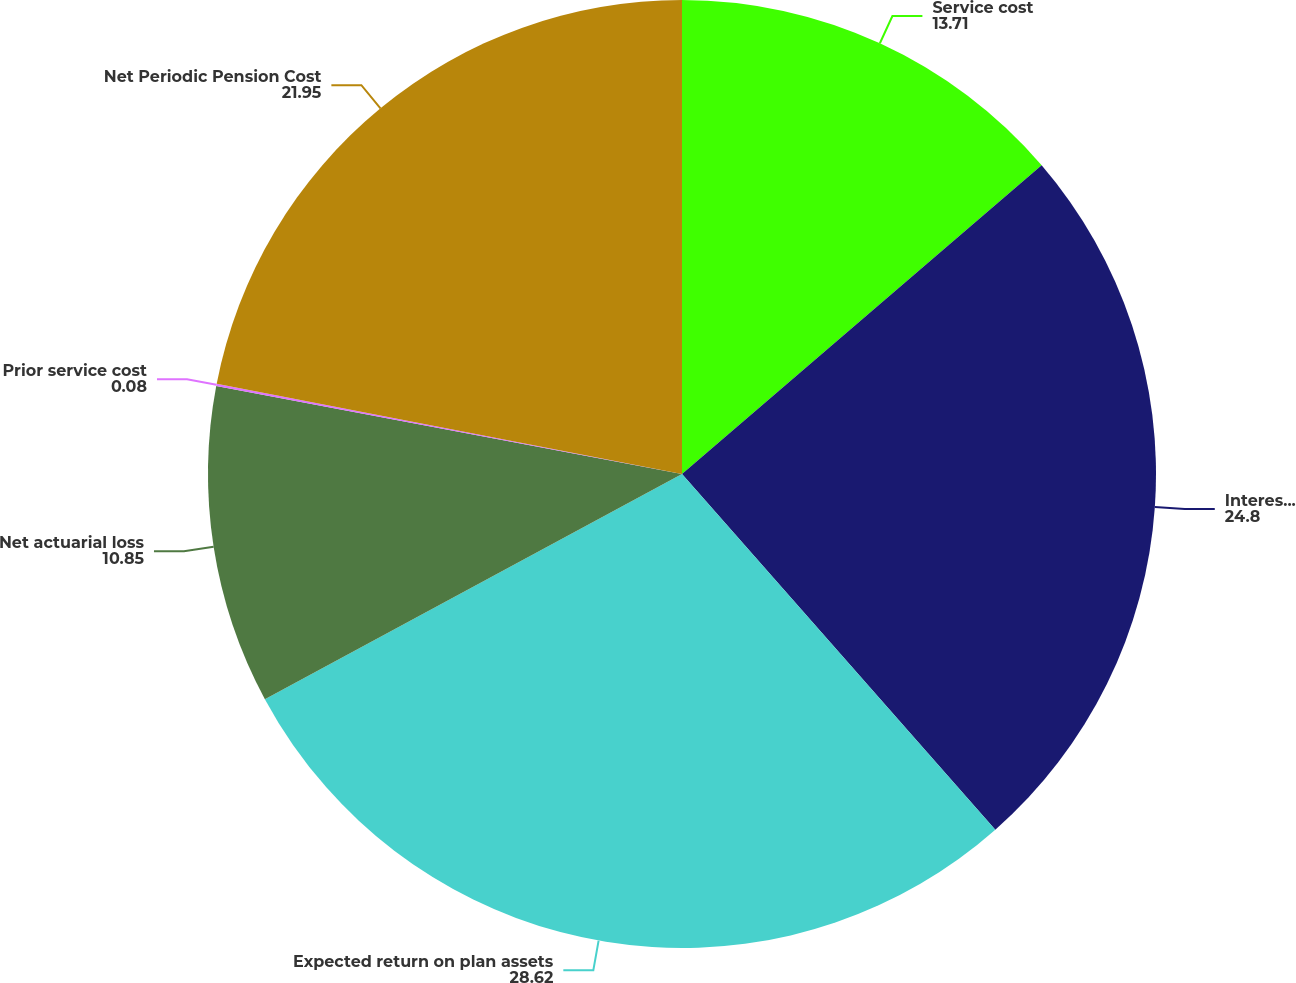<chart> <loc_0><loc_0><loc_500><loc_500><pie_chart><fcel>Service cost<fcel>Interest cost<fcel>Expected return on plan assets<fcel>Net actuarial loss<fcel>Prior service cost<fcel>Net Periodic Pension Cost<nl><fcel>13.71%<fcel>24.8%<fcel>28.62%<fcel>10.85%<fcel>0.08%<fcel>21.95%<nl></chart> 